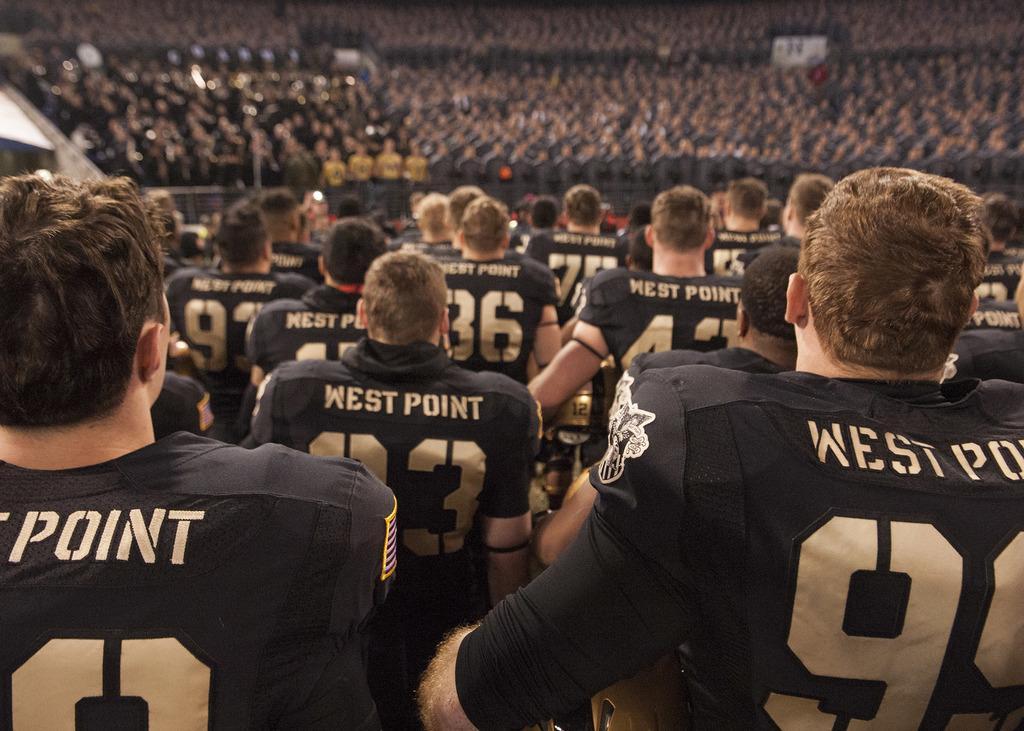Describe this image in one or two sentences. The picture is an animation. In this picture there are lot of people standing wearing jersey. The background is blurred. 